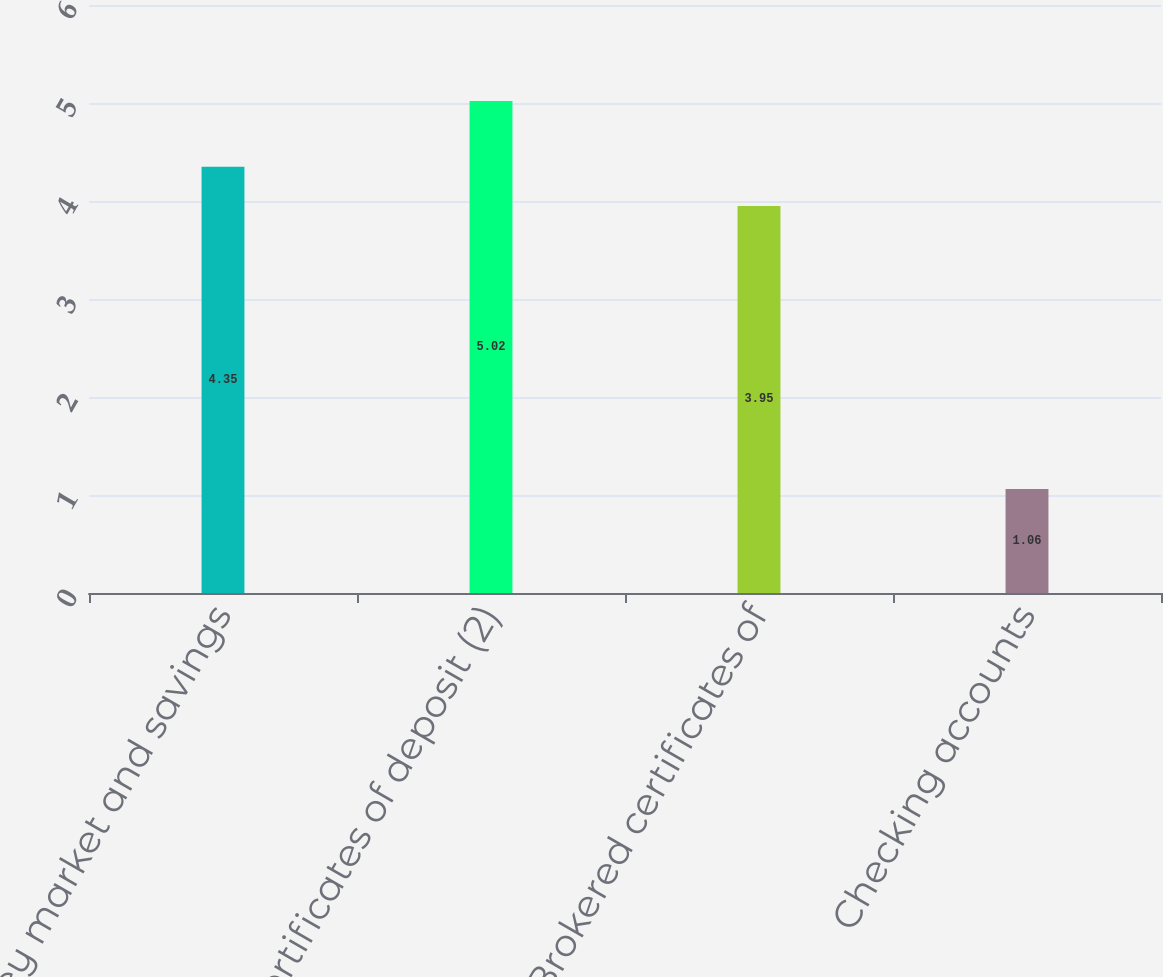Convert chart. <chart><loc_0><loc_0><loc_500><loc_500><bar_chart><fcel>Money market and savings<fcel>Certificates of deposit (2)<fcel>Brokered certificates of<fcel>Checking accounts<nl><fcel>4.35<fcel>5.02<fcel>3.95<fcel>1.06<nl></chart> 